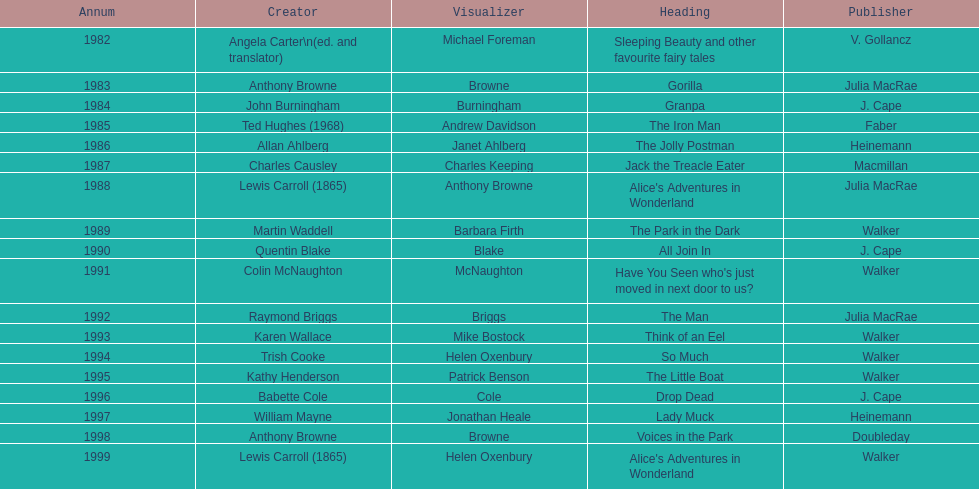How many total titles were published by walker? 5. Help me parse the entirety of this table. {'header': ['Annum', 'Creator', 'Visualizer', 'Heading', 'Publisher'], 'rows': [['1982', 'Angela Carter\\n(ed. and translator)', 'Michael Foreman', 'Sleeping Beauty and other favourite fairy tales', 'V. Gollancz'], ['1983', 'Anthony Browne', 'Browne', 'Gorilla', 'Julia MacRae'], ['1984', 'John Burningham', 'Burningham', 'Granpa', 'J. Cape'], ['1985', 'Ted Hughes (1968)', 'Andrew Davidson', 'The Iron Man', 'Faber'], ['1986', 'Allan Ahlberg', 'Janet Ahlberg', 'The Jolly Postman', 'Heinemann'], ['1987', 'Charles Causley', 'Charles Keeping', 'Jack the Treacle Eater', 'Macmillan'], ['1988', 'Lewis Carroll (1865)', 'Anthony Browne', "Alice's Adventures in Wonderland", 'Julia MacRae'], ['1989', 'Martin Waddell', 'Barbara Firth', 'The Park in the Dark', 'Walker'], ['1990', 'Quentin Blake', 'Blake', 'All Join In', 'J. Cape'], ['1991', 'Colin McNaughton', 'McNaughton', "Have You Seen who's just moved in next door to us?", 'Walker'], ['1992', 'Raymond Briggs', 'Briggs', 'The Man', 'Julia MacRae'], ['1993', 'Karen Wallace', 'Mike Bostock', 'Think of an Eel', 'Walker'], ['1994', 'Trish Cooke', 'Helen Oxenbury', 'So Much', 'Walker'], ['1995', 'Kathy Henderson', 'Patrick Benson', 'The Little Boat', 'Walker'], ['1996', 'Babette Cole', 'Cole', 'Drop Dead', 'J. Cape'], ['1997', 'William Mayne', 'Jonathan Heale', 'Lady Muck', 'Heinemann'], ['1998', 'Anthony Browne', 'Browne', 'Voices in the Park', 'Doubleday'], ['1999', 'Lewis Carroll (1865)', 'Helen Oxenbury', "Alice's Adventures in Wonderland", 'Walker']]} 